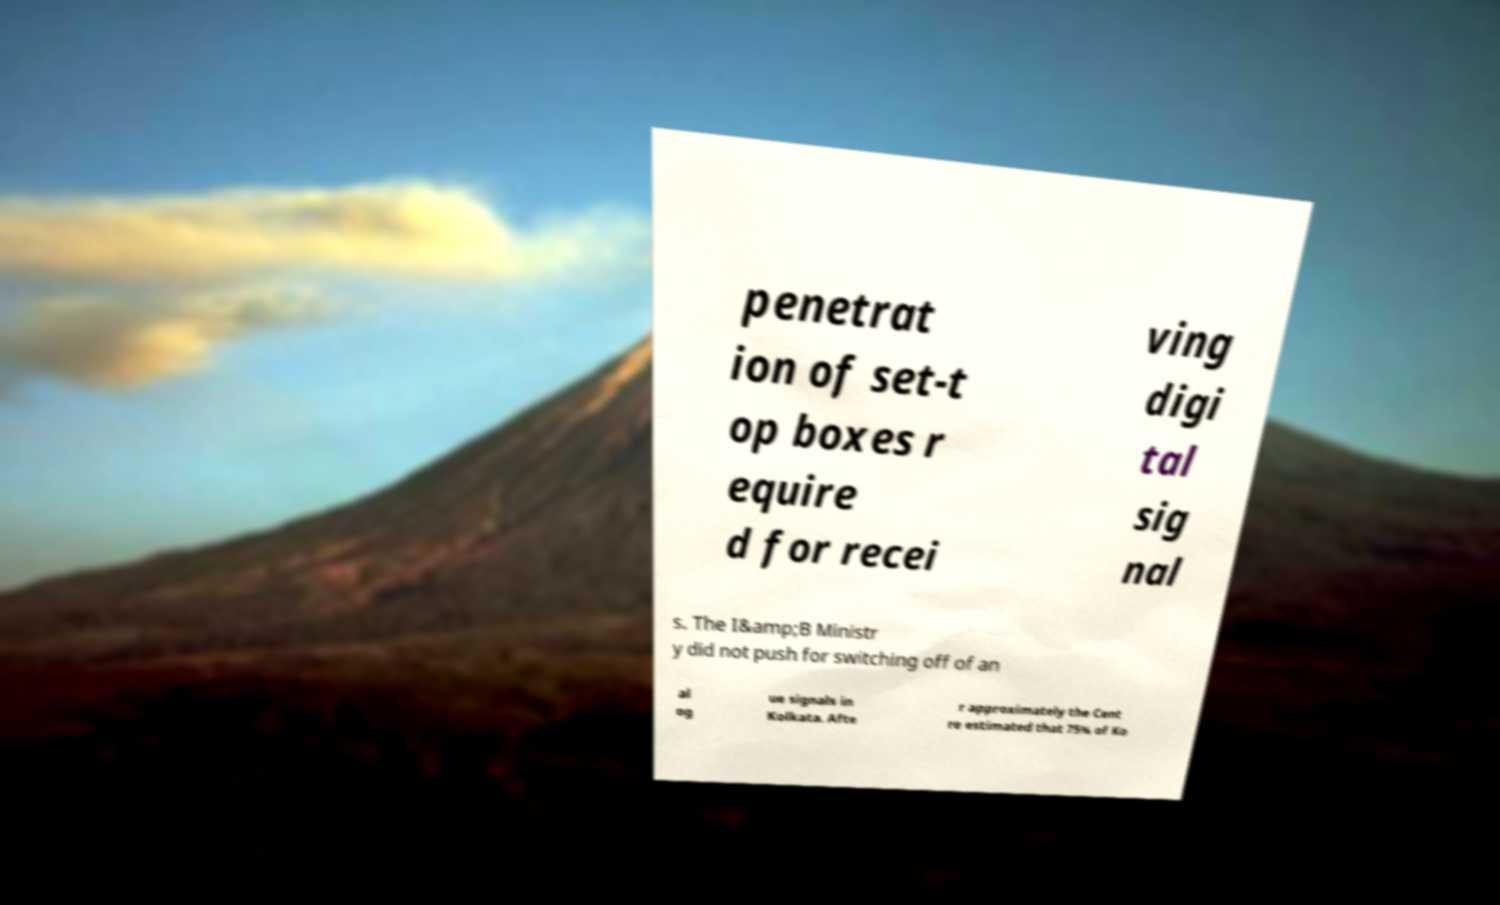Can you read and provide the text displayed in the image?This photo seems to have some interesting text. Can you extract and type it out for me? penetrat ion of set-t op boxes r equire d for recei ving digi tal sig nal s. The I&amp;B Ministr y did not push for switching off of an al og ue signals in Kolkata. Afte r approximately the Cent re estimated that 75% of Ko 